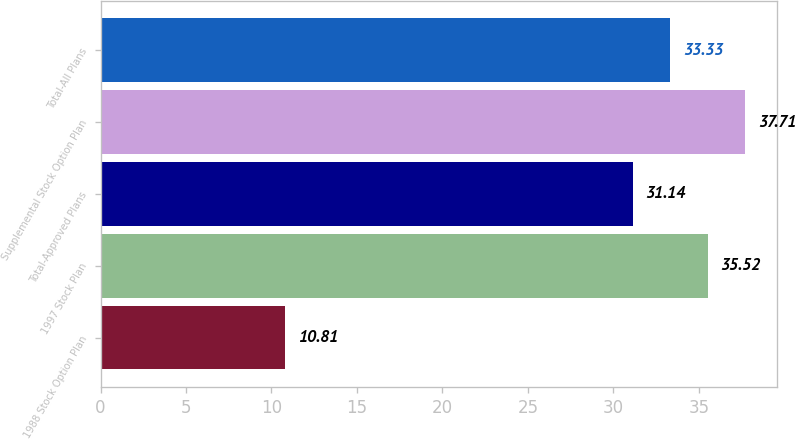<chart> <loc_0><loc_0><loc_500><loc_500><bar_chart><fcel>1988 Stock Option Plan<fcel>1997 Stock Plan<fcel>Total-Approved Plans<fcel>Supplemental Stock Option Plan<fcel>Total-All Plans<nl><fcel>10.81<fcel>35.52<fcel>31.14<fcel>37.71<fcel>33.33<nl></chart> 